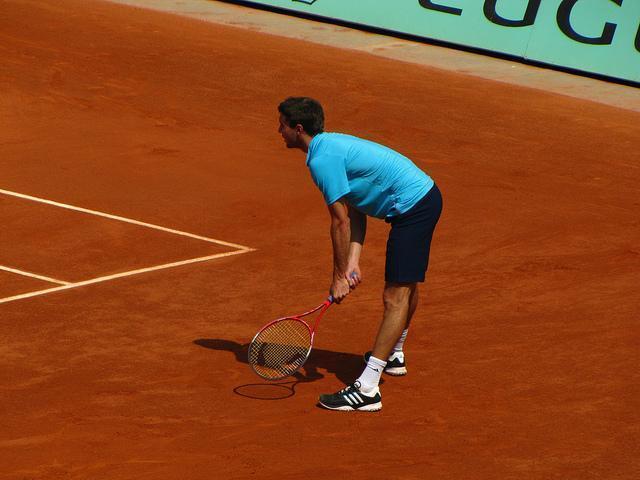How many people are wearing hats?
Give a very brief answer. 0. How many tennis rackets can you see?
Give a very brief answer. 1. 